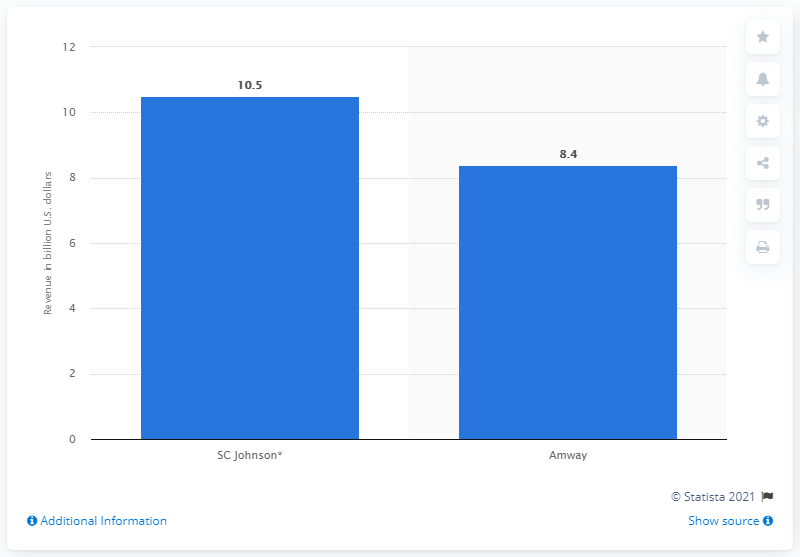Identify some key points in this picture. According to a 2020 estimate, the revenue of SC Johnson was approximately 10.5 billion U.S. dollars. 